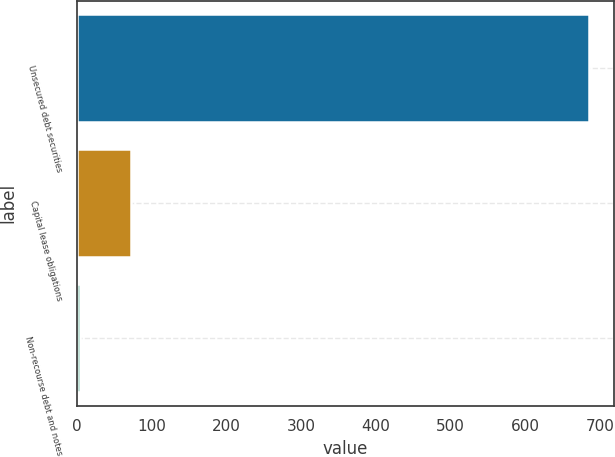Convert chart. <chart><loc_0><loc_0><loc_500><loc_500><bar_chart><fcel>Unsecured debt securities<fcel>Capital lease obligations<fcel>Non-recourse debt and notes<nl><fcel>685<fcel>73<fcel>5<nl></chart> 